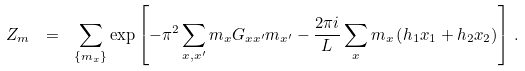Convert formula to latex. <formula><loc_0><loc_0><loc_500><loc_500>Z _ { m } \ = \ \sum _ { \{ m _ { x } \} } \exp \left [ - \pi ^ { 2 } \sum _ { x , x ^ { \prime } } m _ { x } G _ { x x ^ { \prime } } m _ { x ^ { \prime } } - \frac { 2 \pi i } { L } \sum _ { x } m _ { x } \left ( h _ { 1 } x _ { 1 } + h _ { 2 } x _ { 2 } \right ) \right ] \, .</formula> 